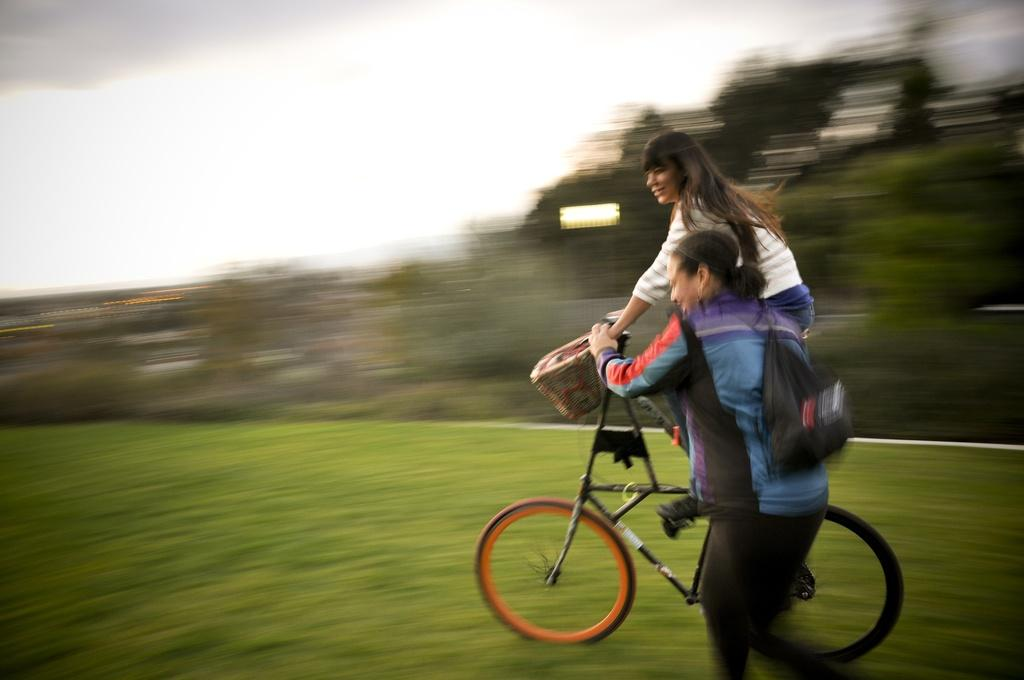What is the main subject of the image? There is a woman riding a bicycle in the image. Can you describe the other woman in the image? The second woman is on the right side of the image, wearing a bag, and holding a bicycle handle. What can be seen in the background of the image? There is a sky and trees visible in the background of the image. What type of kettle is being used by the woman riding the bicycle in the image? There is no kettle present in the image; it features two women and bicycles. Can you tell me how many snakes are visible in the image? There are no snakes visible in the image; it features two women and bicycles. 